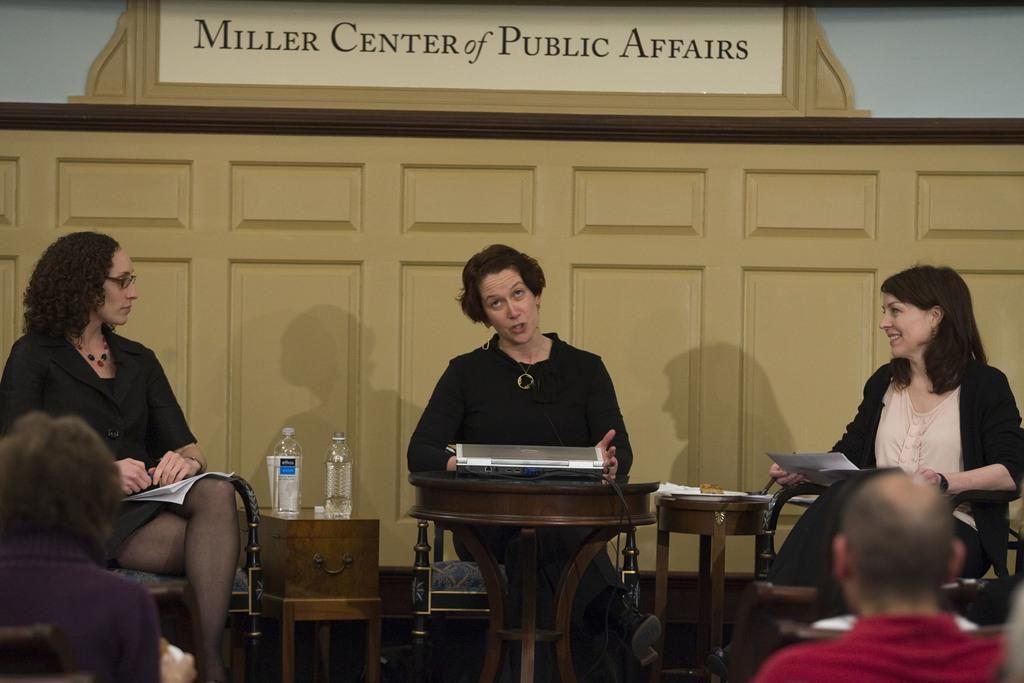How many people are present in the image? There are five people in the image. What are the people doing in the image? The people are sitting on chairs. Can you identify any objects in the image besides the people? Yes, there is a bottle in the image. Is there anyone holding anything in the image? Yes, one person is holding a paper in their hand. What type of cakes are being served on the desk in the image? There is no desk or cakes present in the image. 